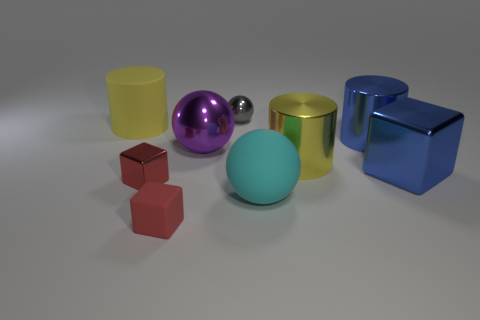Can you describe the texture of the objects? Certainly, the objects in the image have a smooth and shiny texture, suggesting they are made from materials such as polished metal or plastic. 